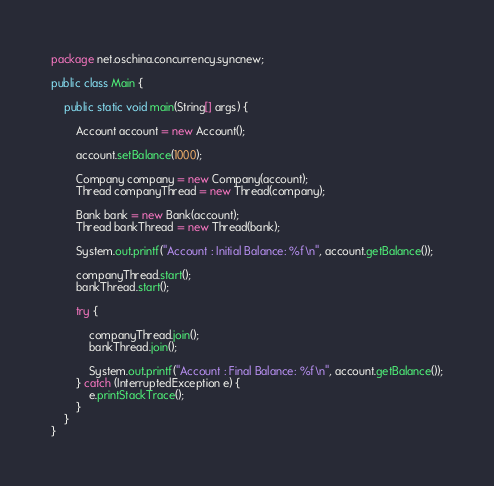Convert code to text. <code><loc_0><loc_0><loc_500><loc_500><_Java_>package net.oschina.concurrency.syncnew;

public class Main {

	public static void main(String[] args) {

		Account account = new Account();

		account.setBalance(1000);

		Company company = new Company(account);
		Thread companyThread = new Thread(company);

		Bank bank = new Bank(account);
		Thread bankThread = new Thread(bank);

		System.out.printf("Account : Initial Balance: %f\n", account.getBalance());

		companyThread.start();
		bankThread.start();

		try {

			companyThread.join();
			bankThread.join();

			System.out.printf("Account : Final Balance: %f\n", account.getBalance());
		} catch (InterruptedException e) {
			e.printStackTrace();
		}
	}
}
</code> 